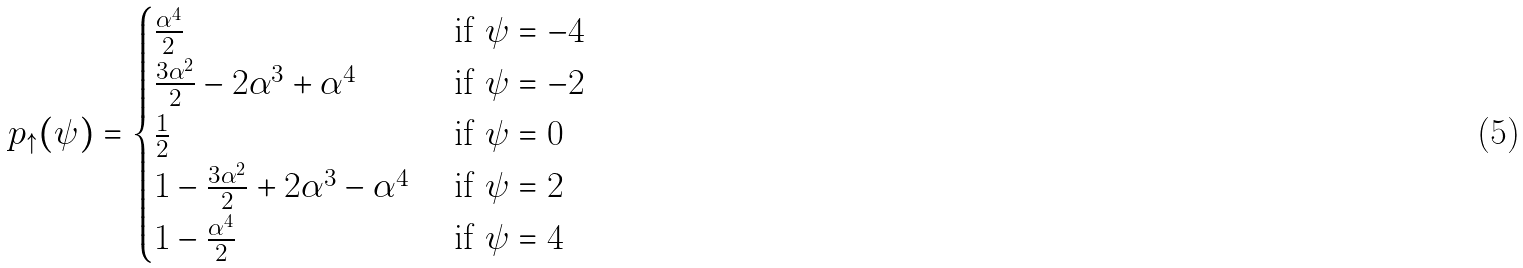Convert formula to latex. <formula><loc_0><loc_0><loc_500><loc_500>p _ { \uparrow } ( \psi ) = \begin{cases} \frac { \alpha ^ { 4 } } { 2 } & \text { if } \psi = - 4 \\ \frac { 3 \alpha ^ { 2 } } { 2 } - 2 \alpha ^ { 3 } + \alpha ^ { 4 } & \text { if } \psi = - 2 \\ \frac { 1 } { 2 } & \text { if } \psi = 0 \\ 1 - \frac { 3 \alpha ^ { 2 } } { 2 } + 2 \alpha ^ { 3 } - \alpha ^ { 4 } & \text { if } \psi = 2 \\ 1 - \frac { \alpha ^ { 4 } } { 2 } & \text { if } \psi = 4 \end{cases}</formula> 